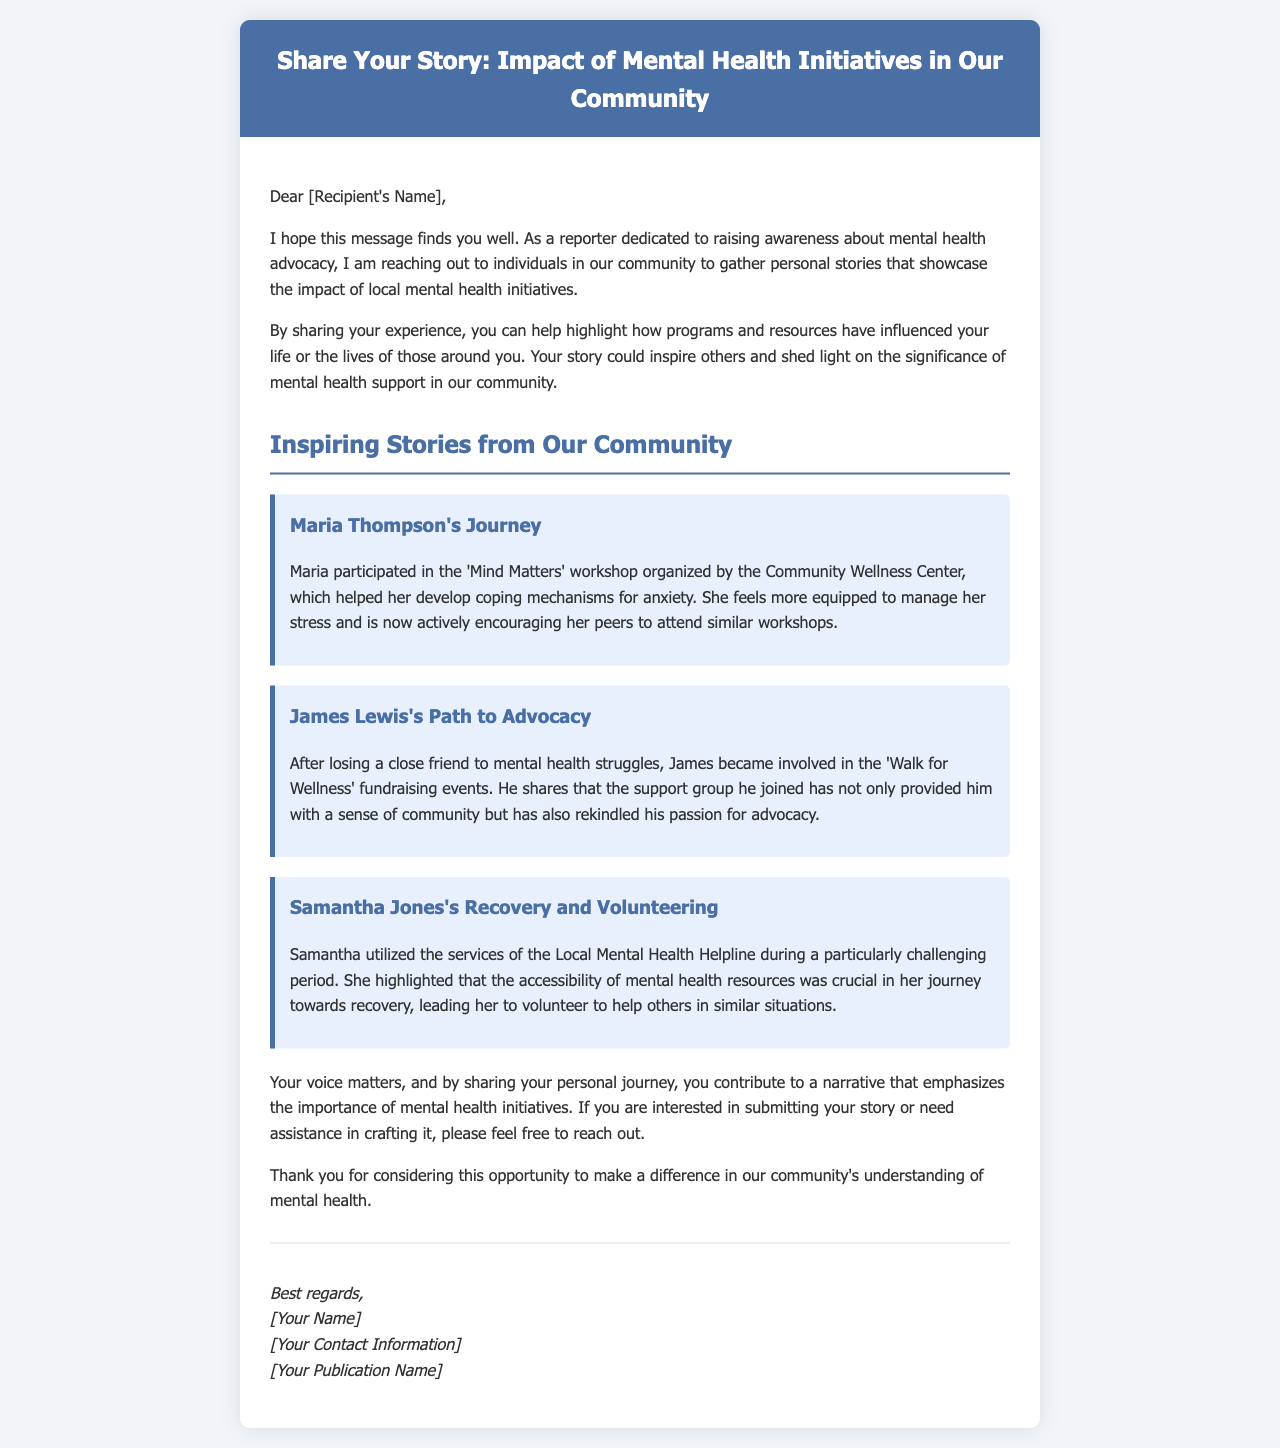What is the title of the email? The title is prominently displayed in the header section of the document.
Answer: Share Your Story: Impact of Mental Health Initiatives in Our Community Who is the first individual's story highlighted in the email? The name of the first individual mentioned in the stories section is indicated by a header in the content.
Answer: Maria Thompson What workshop did Maria Thompson participate in? The text specifies the name of the workshop associated with Maria's story.
Answer: Mind Matters What event did James Lewis become involved in after his friend's passing? The email outlines the specific event James engaged with for advocacy.
Answer: Walk for Wellness How did Samantha Jones first seek help during her challenging period? Samantha's initial method of seeking support is detailed in her story description.
Answer: Local Mental Health Helpline What is the main purpose of sharing personal stories, according to the email? The email explicitly states the significance of sharing stories and its intended impact.
Answer: Highlight the impact of local mental health initiatives Who signs off the email? The sign-off section provides the name of the sender, which is customary in emails.
Answer: [Your Name] What organization organized the 'Mind Matters' workshop? The text references the organization responsible for hosting the workshop Maria attended.
Answer: Community Wellness Center 